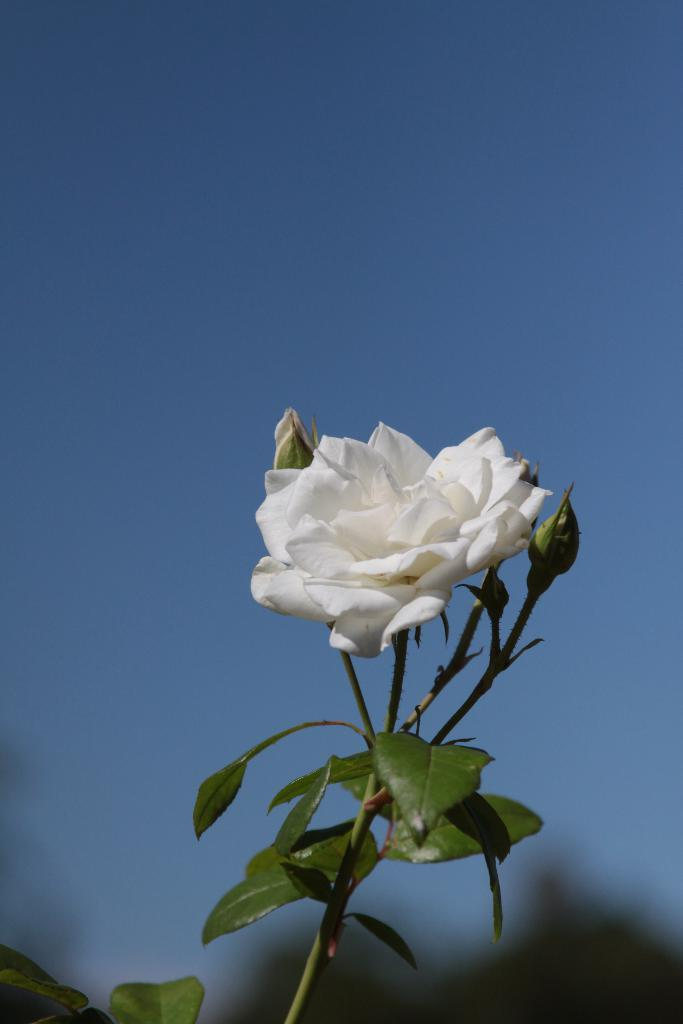What type of flower is present in the image? There is a white color flower in the image. What stage of growth are some of the flowers in the image? There are buds in the image. What other plant parts can be seen in the image? There are leaves in the image. What can be seen in the background of the image? The sky is visible in the background of the image. Where is the camera located in the image? There is no camera present in the image. What type of tub can be seen in the image? There is no tub present in the image. 